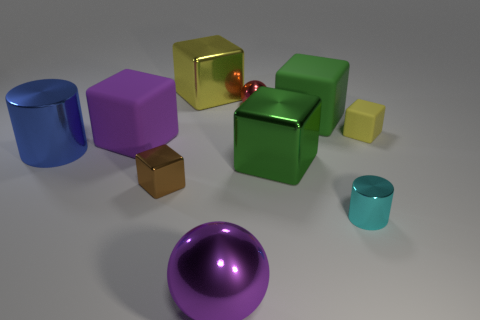What is the size of the object that is in front of the brown cube and on the right side of the small shiny sphere?
Ensure brevity in your answer.  Small. The metallic ball that is behind the rubber object that is behind the small yellow object is what color?
Ensure brevity in your answer.  Red. How many yellow things are either balls or small matte blocks?
Give a very brief answer. 1. What color is the tiny thing that is right of the red ball and behind the brown metal object?
Your answer should be compact. Yellow. How many small objects are either cylinders or cyan cylinders?
Ensure brevity in your answer.  1. There is a green rubber thing that is the same shape as the brown object; what size is it?
Ensure brevity in your answer.  Large. There is a blue shiny thing; what shape is it?
Provide a succinct answer. Cylinder. Is the material of the tiny cyan object the same as the green cube that is behind the blue metal cylinder?
Offer a terse response. No. How many metallic things are either tiny yellow cubes or small red blocks?
Your response must be concise. 0. There is a cylinder that is right of the large green metal block; what is its size?
Provide a short and direct response. Small. 